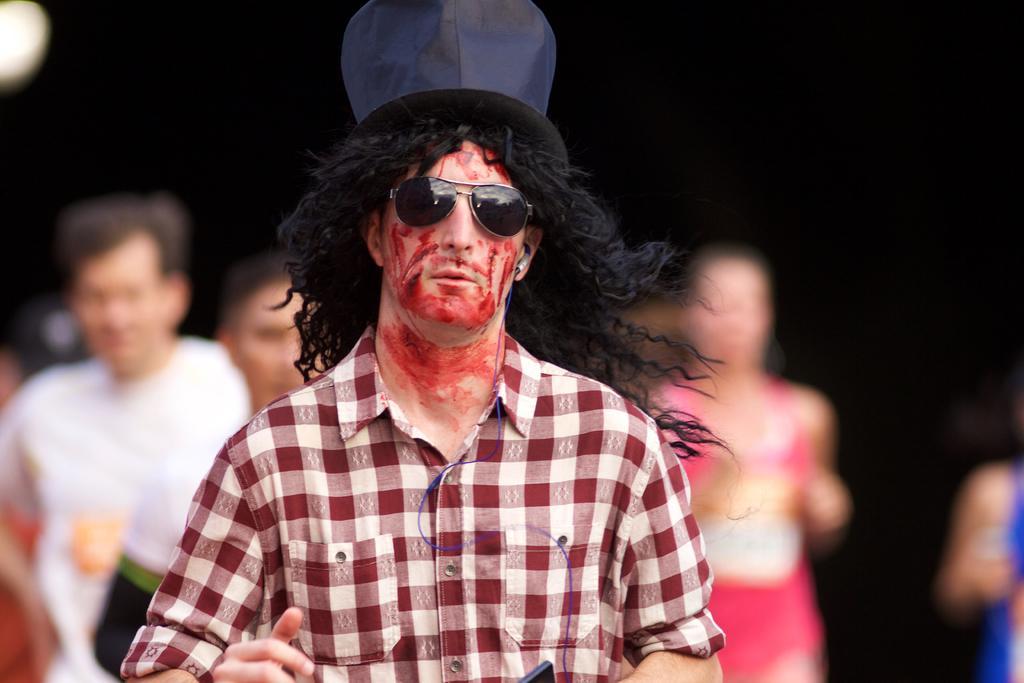Could you give a brief overview of what you see in this image? In this picture we can see a man with goggles and a hat. Behind the man, there are blurred people and a dark background. 